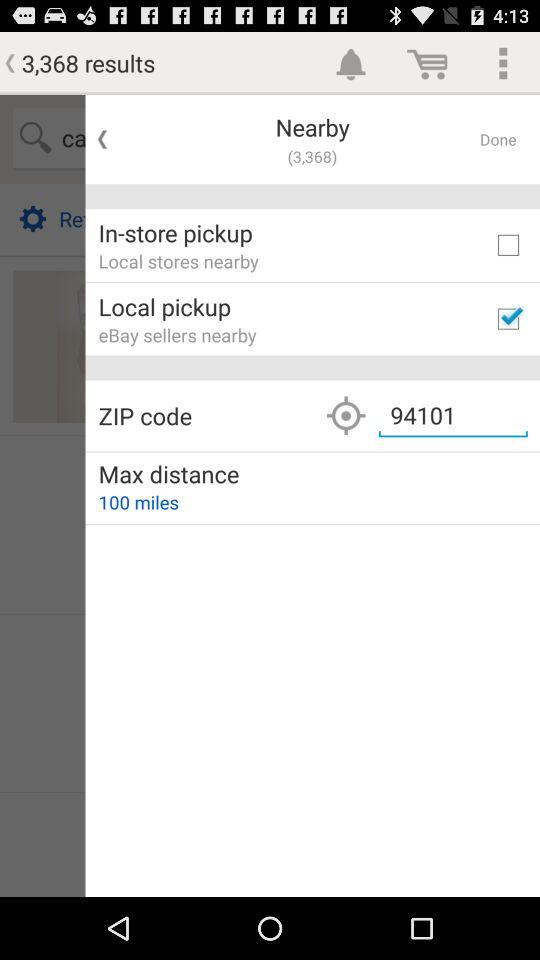What is the ZIP Code? The ZIP Code is 94101. 